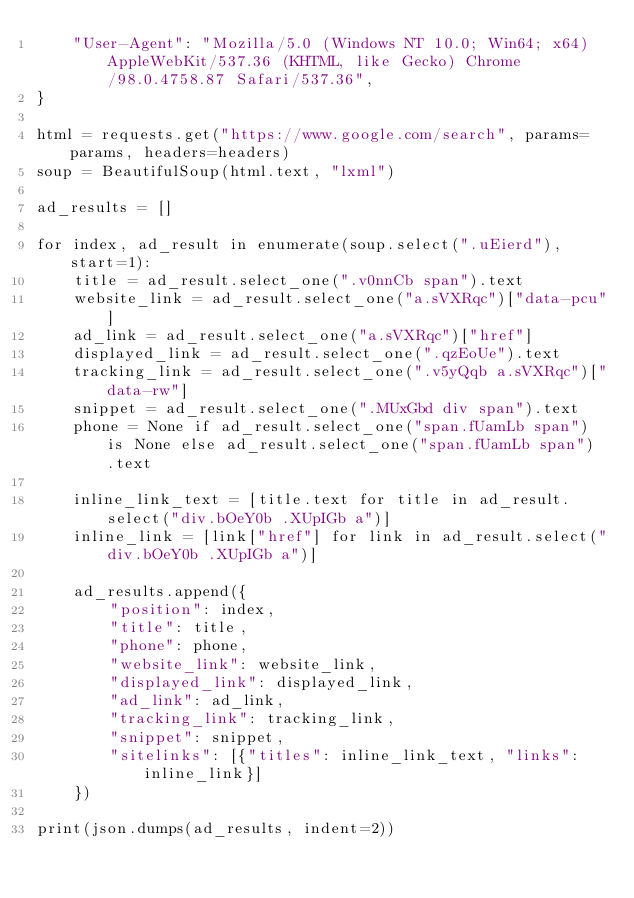<code> <loc_0><loc_0><loc_500><loc_500><_Python_>    "User-Agent": "Mozilla/5.0 (Windows NT 10.0; Win64; x64) AppleWebKit/537.36 (KHTML, like Gecko) Chrome/98.0.4758.87 Safari/537.36",
}

html = requests.get("https://www.google.com/search", params=params, headers=headers)
soup = BeautifulSoup(html.text, "lxml")

ad_results = []

for index, ad_result in enumerate(soup.select(".uEierd"), start=1):
    title = ad_result.select_one(".v0nnCb span").text
    website_link = ad_result.select_one("a.sVXRqc")["data-pcu"]
    ad_link = ad_result.select_one("a.sVXRqc")["href"]
    displayed_link = ad_result.select_one(".qzEoUe").text
    tracking_link = ad_result.select_one(".v5yQqb a.sVXRqc")["data-rw"]
    snippet = ad_result.select_one(".MUxGbd div span").text
    phone = None if ad_result.select_one("span.fUamLb span") is None else ad_result.select_one("span.fUamLb span") .text

    inline_link_text = [title.text for title in ad_result.select("div.bOeY0b .XUpIGb a")]
    inline_link = [link["href"] for link in ad_result.select("div.bOeY0b .XUpIGb a")]

    ad_results.append({
        "position": index,
        "title": title,
        "phone": phone,
        "website_link": website_link,
        "displayed_link": displayed_link,
        "ad_link": ad_link,
        "tracking_link": tracking_link,
        "snippet": snippet,
        "sitelinks": [{"titles": inline_link_text, "links": inline_link}]
    })

print(json.dumps(ad_results, indent=2))</code> 